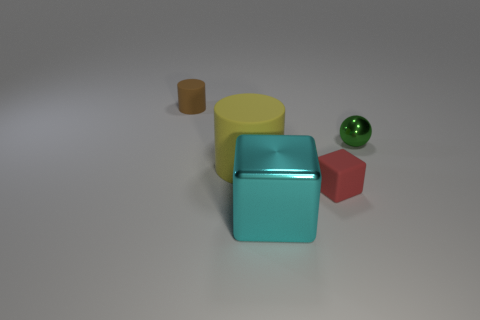Is there any indication of what the big rubber object is used for? The big rubber object doesn't have any distinguishing features that suggest a specific use. It's an abstract representation, more likely used for educational purposes or as a prop to demonstrate principles of geometry, materials, and colors in a visual context. 